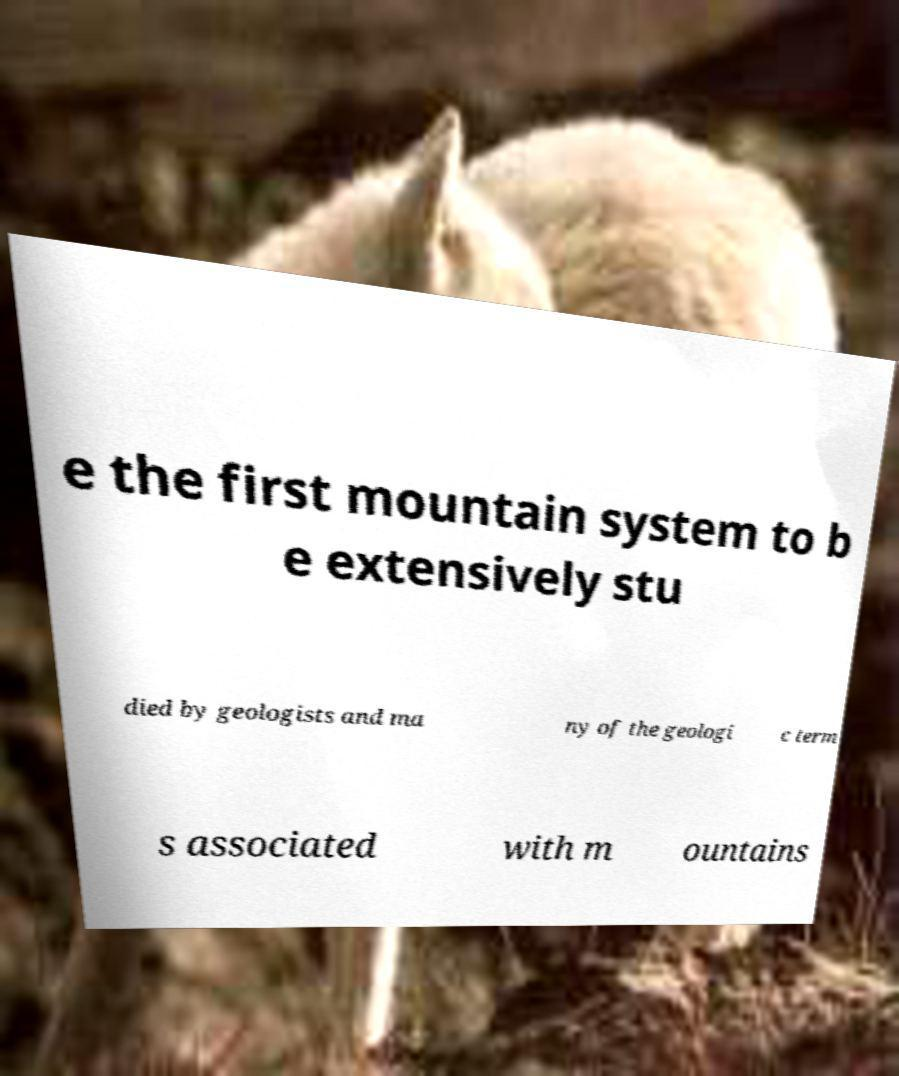Can you accurately transcribe the text from the provided image for me? e the first mountain system to b e extensively stu died by geologists and ma ny of the geologi c term s associated with m ountains 